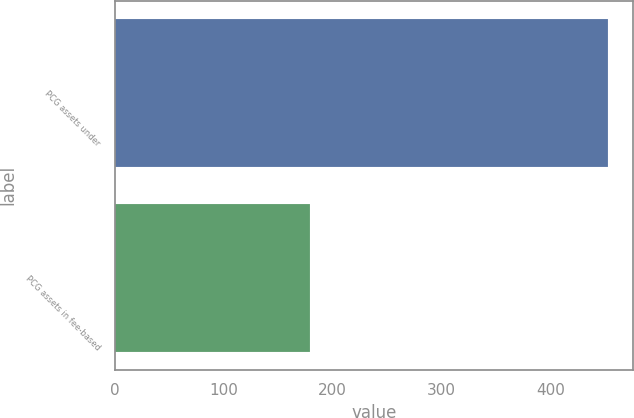Convert chart to OTSL. <chart><loc_0><loc_0><loc_500><loc_500><bar_chart><fcel>PCG assets under<fcel>PCG assets in fee-based<nl><fcel>453.3<fcel>179.4<nl></chart> 